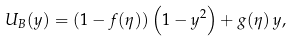Convert formula to latex. <formula><loc_0><loc_0><loc_500><loc_500>U _ { B } ( y ) = \left ( 1 - f ( \eta ) \right ) \left ( 1 - y ^ { 2 } \right ) + g ( \eta ) \, y ,</formula> 